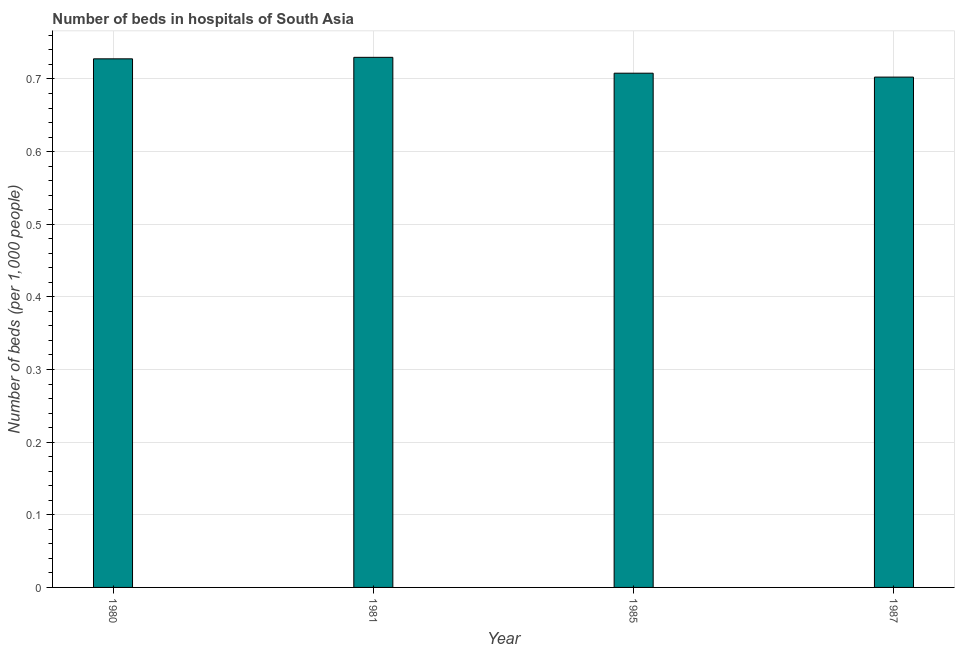Does the graph contain any zero values?
Provide a succinct answer. No. What is the title of the graph?
Offer a terse response. Number of beds in hospitals of South Asia. What is the label or title of the X-axis?
Keep it short and to the point. Year. What is the label or title of the Y-axis?
Provide a short and direct response. Number of beds (per 1,0 people). What is the number of hospital beds in 1985?
Offer a very short reply. 0.71. Across all years, what is the maximum number of hospital beds?
Give a very brief answer. 0.73. Across all years, what is the minimum number of hospital beds?
Give a very brief answer. 0.7. What is the sum of the number of hospital beds?
Keep it short and to the point. 2.87. What is the difference between the number of hospital beds in 1980 and 1987?
Provide a short and direct response. 0.03. What is the average number of hospital beds per year?
Give a very brief answer. 0.72. What is the median number of hospital beds?
Make the answer very short. 0.72. In how many years, is the number of hospital beds greater than 0.74 %?
Provide a succinct answer. 0. What is the difference between the highest and the second highest number of hospital beds?
Offer a very short reply. 0. In how many years, is the number of hospital beds greater than the average number of hospital beds taken over all years?
Ensure brevity in your answer.  2. How many bars are there?
Make the answer very short. 4. Are all the bars in the graph horizontal?
Provide a short and direct response. No. How many years are there in the graph?
Keep it short and to the point. 4. Are the values on the major ticks of Y-axis written in scientific E-notation?
Make the answer very short. No. What is the Number of beds (per 1,000 people) of 1980?
Your answer should be compact. 0.73. What is the Number of beds (per 1,000 people) in 1981?
Offer a very short reply. 0.73. What is the Number of beds (per 1,000 people) of 1985?
Keep it short and to the point. 0.71. What is the Number of beds (per 1,000 people) of 1987?
Your response must be concise. 0.7. What is the difference between the Number of beds (per 1,000 people) in 1980 and 1981?
Provide a succinct answer. -0. What is the difference between the Number of beds (per 1,000 people) in 1980 and 1985?
Your answer should be compact. 0.02. What is the difference between the Number of beds (per 1,000 people) in 1980 and 1987?
Offer a very short reply. 0.03. What is the difference between the Number of beds (per 1,000 people) in 1981 and 1985?
Ensure brevity in your answer.  0.02. What is the difference between the Number of beds (per 1,000 people) in 1981 and 1987?
Offer a very short reply. 0.03. What is the difference between the Number of beds (per 1,000 people) in 1985 and 1987?
Ensure brevity in your answer.  0.01. What is the ratio of the Number of beds (per 1,000 people) in 1980 to that in 1981?
Give a very brief answer. 1. What is the ratio of the Number of beds (per 1,000 people) in 1980 to that in 1985?
Make the answer very short. 1.03. What is the ratio of the Number of beds (per 1,000 people) in 1980 to that in 1987?
Offer a terse response. 1.04. What is the ratio of the Number of beds (per 1,000 people) in 1981 to that in 1985?
Ensure brevity in your answer.  1.03. What is the ratio of the Number of beds (per 1,000 people) in 1981 to that in 1987?
Your answer should be compact. 1.04. 